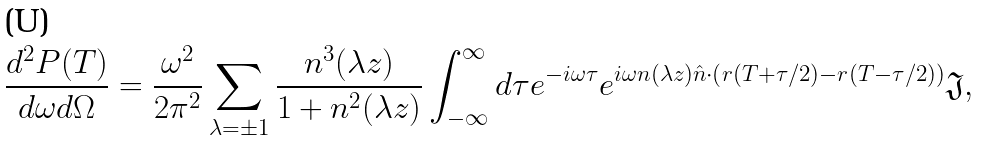Convert formula to latex. <formula><loc_0><loc_0><loc_500><loc_500>\frac { d ^ { 2 } P ( T ) } { d \omega d \Omega } = \frac { \omega ^ { 2 } } { 2 \pi ^ { 2 } } \sum _ { \lambda = \pm 1 } \frac { n ^ { 3 } ( \lambda z ) } { 1 + n ^ { 2 } ( \lambda z ) } \int _ { - \infty } ^ { \infty } d \tau e ^ { - i \omega \tau } e ^ { i \omega n ( \lambda z ) \hat { n } \cdot \left ( r ( T + \tau / 2 ) - r ( T - \tau / 2 ) \right ) } \mathfrak { J } ,</formula> 